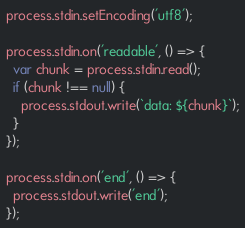Convert code to text. <code><loc_0><loc_0><loc_500><loc_500><_JavaScript_>process.stdin.setEncoding('utf8');

process.stdin.on('readable', () => {
  var chunk = process.stdin.read();
  if (chunk !== null) {
    process.stdout.write(`data: ${chunk}`);
  }
});

process.stdin.on('end', () => {
  process.stdout.write('end');
});</code> 